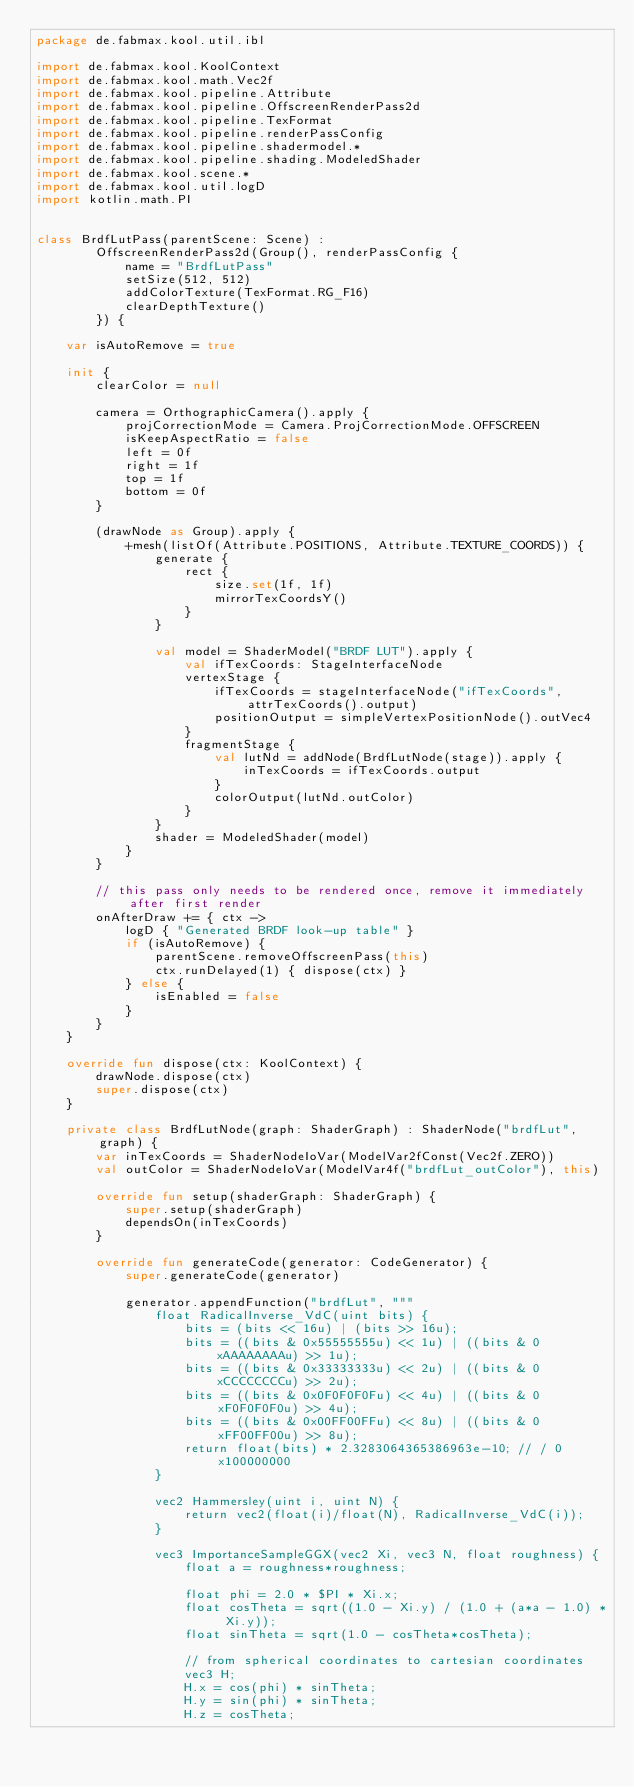Convert code to text. <code><loc_0><loc_0><loc_500><loc_500><_Kotlin_>package de.fabmax.kool.util.ibl

import de.fabmax.kool.KoolContext
import de.fabmax.kool.math.Vec2f
import de.fabmax.kool.pipeline.Attribute
import de.fabmax.kool.pipeline.OffscreenRenderPass2d
import de.fabmax.kool.pipeline.TexFormat
import de.fabmax.kool.pipeline.renderPassConfig
import de.fabmax.kool.pipeline.shadermodel.*
import de.fabmax.kool.pipeline.shading.ModeledShader
import de.fabmax.kool.scene.*
import de.fabmax.kool.util.logD
import kotlin.math.PI


class BrdfLutPass(parentScene: Scene) :
        OffscreenRenderPass2d(Group(), renderPassConfig {
            name = "BrdfLutPass"
            setSize(512, 512)
            addColorTexture(TexFormat.RG_F16)
            clearDepthTexture()
        }) {

    var isAutoRemove = true

    init {
        clearColor = null

        camera = OrthographicCamera().apply {
            projCorrectionMode = Camera.ProjCorrectionMode.OFFSCREEN
            isKeepAspectRatio = false
            left = 0f
            right = 1f
            top = 1f
            bottom = 0f
        }

        (drawNode as Group).apply {
            +mesh(listOf(Attribute.POSITIONS, Attribute.TEXTURE_COORDS)) {
                generate {
                    rect {
                        size.set(1f, 1f)
                        mirrorTexCoordsY()
                    }
                }

                val model = ShaderModel("BRDF LUT").apply {
                    val ifTexCoords: StageInterfaceNode
                    vertexStage {
                        ifTexCoords = stageInterfaceNode("ifTexCoords", attrTexCoords().output)
                        positionOutput = simpleVertexPositionNode().outVec4
                    }
                    fragmentStage {
                        val lutNd = addNode(BrdfLutNode(stage)).apply {
                            inTexCoords = ifTexCoords.output
                        }
                        colorOutput(lutNd.outColor)
                    }
                }
                shader = ModeledShader(model)
            }
        }

        // this pass only needs to be rendered once, remove it immediately after first render
        onAfterDraw += { ctx ->
            logD { "Generated BRDF look-up table" }
            if (isAutoRemove) {
                parentScene.removeOffscreenPass(this)
                ctx.runDelayed(1) { dispose(ctx) }
            } else {
                isEnabled = false
            }
        }
    }

    override fun dispose(ctx: KoolContext) {
        drawNode.dispose(ctx)
        super.dispose(ctx)
    }

    private class BrdfLutNode(graph: ShaderGraph) : ShaderNode("brdfLut", graph) {
        var inTexCoords = ShaderNodeIoVar(ModelVar2fConst(Vec2f.ZERO))
        val outColor = ShaderNodeIoVar(ModelVar4f("brdfLut_outColor"), this)

        override fun setup(shaderGraph: ShaderGraph) {
            super.setup(shaderGraph)
            dependsOn(inTexCoords)
        }

        override fun generateCode(generator: CodeGenerator) {
            super.generateCode(generator)

            generator.appendFunction("brdfLut", """
                float RadicalInverse_VdC(uint bits) {
                    bits = (bits << 16u) | (bits >> 16u);
                    bits = ((bits & 0x55555555u) << 1u) | ((bits & 0xAAAAAAAAu) >> 1u);
                    bits = ((bits & 0x33333333u) << 2u) | ((bits & 0xCCCCCCCCu) >> 2u);
                    bits = ((bits & 0x0F0F0F0Fu) << 4u) | ((bits & 0xF0F0F0F0u) >> 4u);
                    bits = ((bits & 0x00FF00FFu) << 8u) | ((bits & 0xFF00FF00u) >> 8u);
                    return float(bits) * 2.3283064365386963e-10; // / 0x100000000
                }
                
                vec2 Hammersley(uint i, uint N) {
                    return vec2(float(i)/float(N), RadicalInverse_VdC(i));
                }
                
                vec3 ImportanceSampleGGX(vec2 Xi, vec3 N, float roughness) {
                    float a = roughness*roughness;
                    
                    float phi = 2.0 * $PI * Xi.x;
                    float cosTheta = sqrt((1.0 - Xi.y) / (1.0 + (a*a - 1.0) * Xi.y));
                    float sinTheta = sqrt(1.0 - cosTheta*cosTheta);
                    
                    // from spherical coordinates to cartesian coordinates
                    vec3 H;
                    H.x = cos(phi) * sinTheta;
                    H.y = sin(phi) * sinTheta;
                    H.z = cosTheta;
                    </code> 